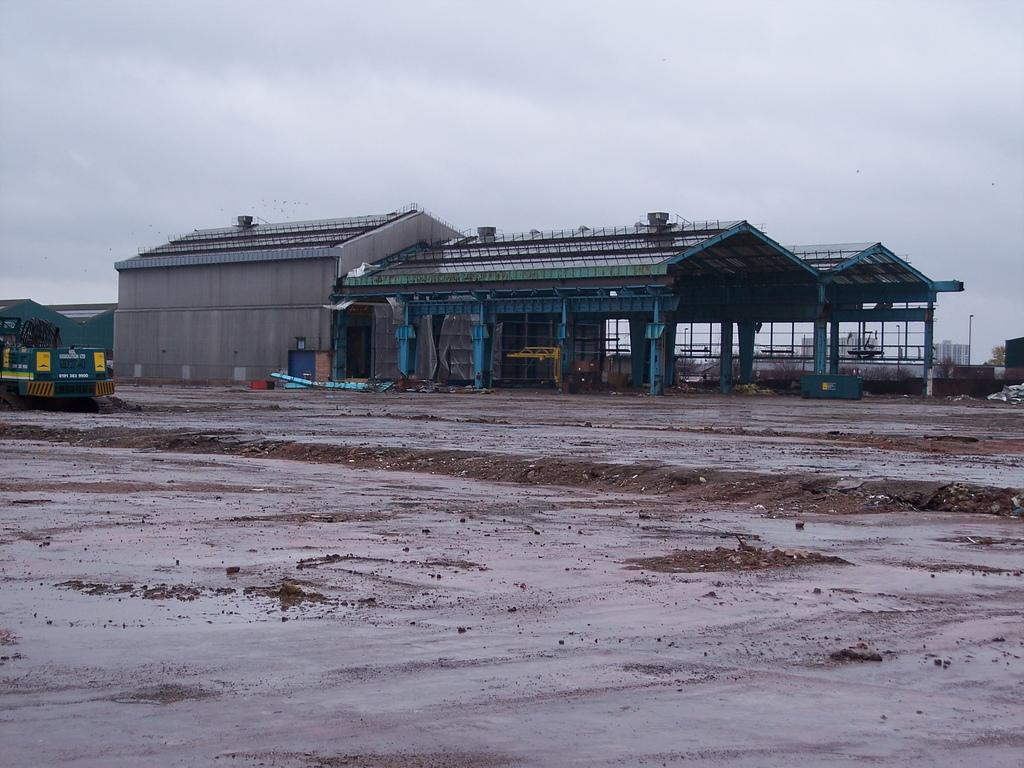What type of vehicle is on the surface in the image? The specific type of vehicle is not mentioned, but there is a vehicle on the surface in the image. What type of structure can be seen in the image? There is a shed in the image. What can be seen in the background of the image? There is a building and a light on a pole in the background of the image. What is visible above the structures in the image? The sky is visible in the background of the image. What type of punishment is being administered to the feather in the image? There is no feather or punishment present in the image. How is the vehicle being used for transport in the image? The specific use of the vehicle for transport is not mentioned in the image, but it is on the surface, which suggests it might be in use. 